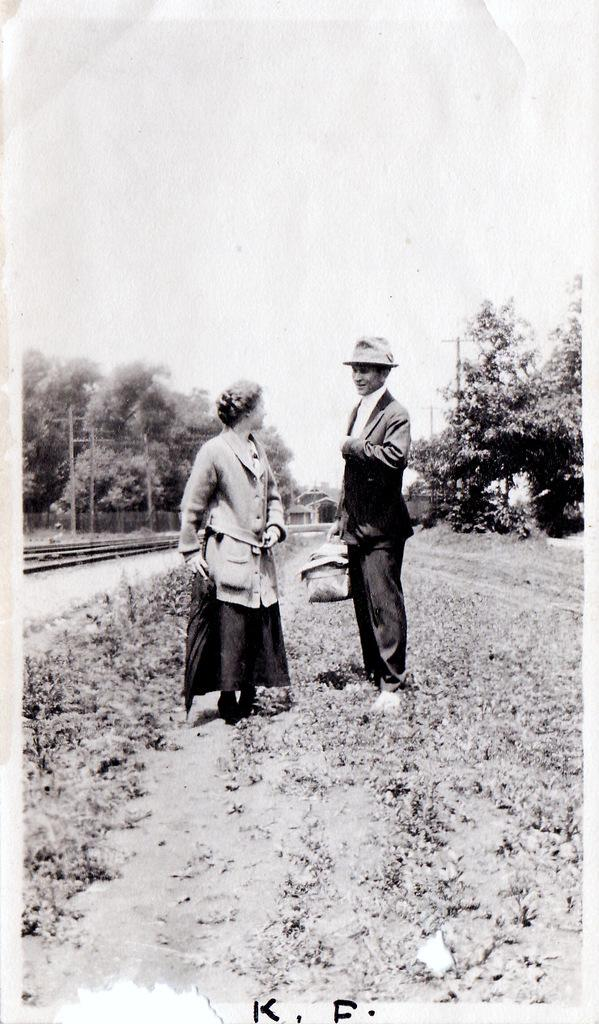How many people are present in the image? There is a man and a woman present in the image. What is the man wearing on his head? The man is wearing a hat. What type of terrain can be seen in the image? There is grass visible in the image. What type of transportation infrastructure is present in the image? There is a train track in the image. What other natural elements can be seen in the image? There are trees in the image. What part of the natural environment is visible in the image? The sky is visible in the image. What type of polish is the woman applying to her tongue in the image? There is no indication in the image that the woman is applying any polish to her tongue. 